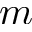Convert formula to latex. <formula><loc_0><loc_0><loc_500><loc_500>m</formula> 